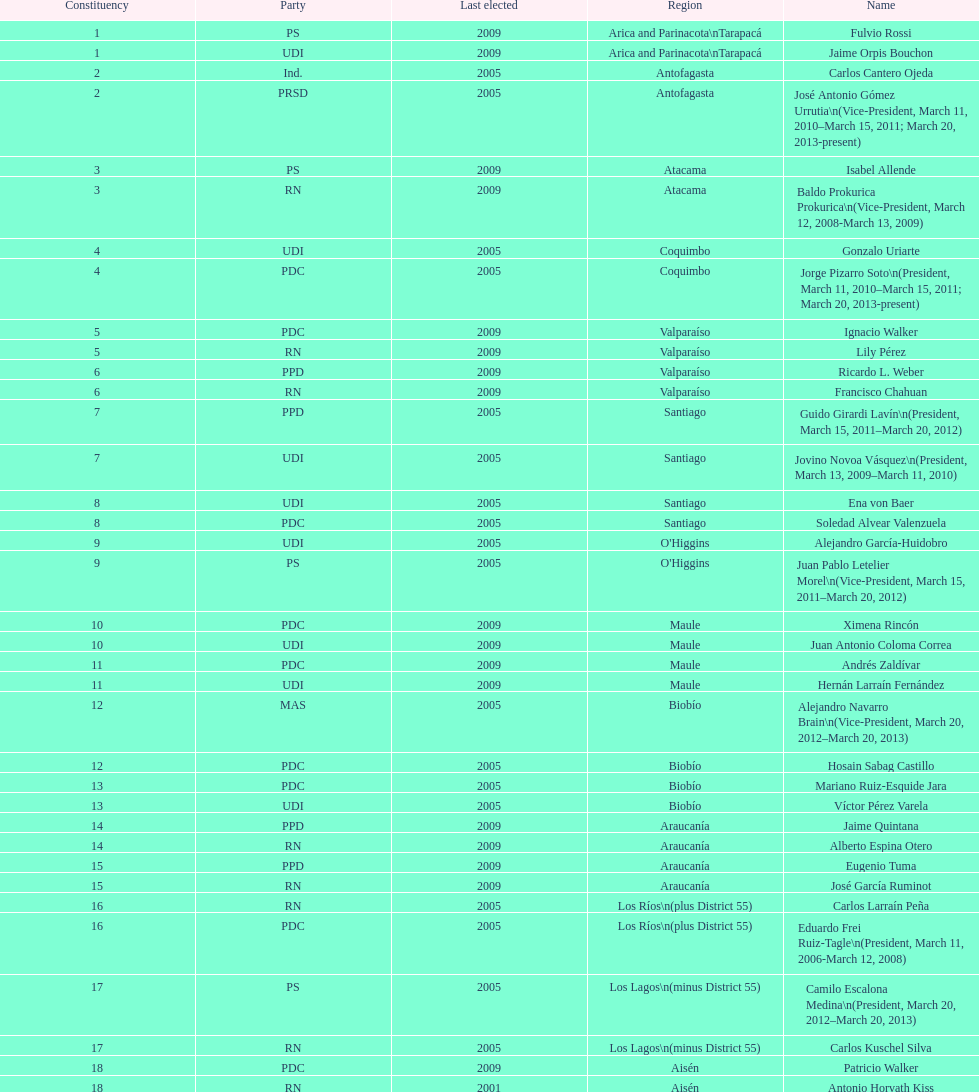What is the last region listed on the table? Magallanes. 